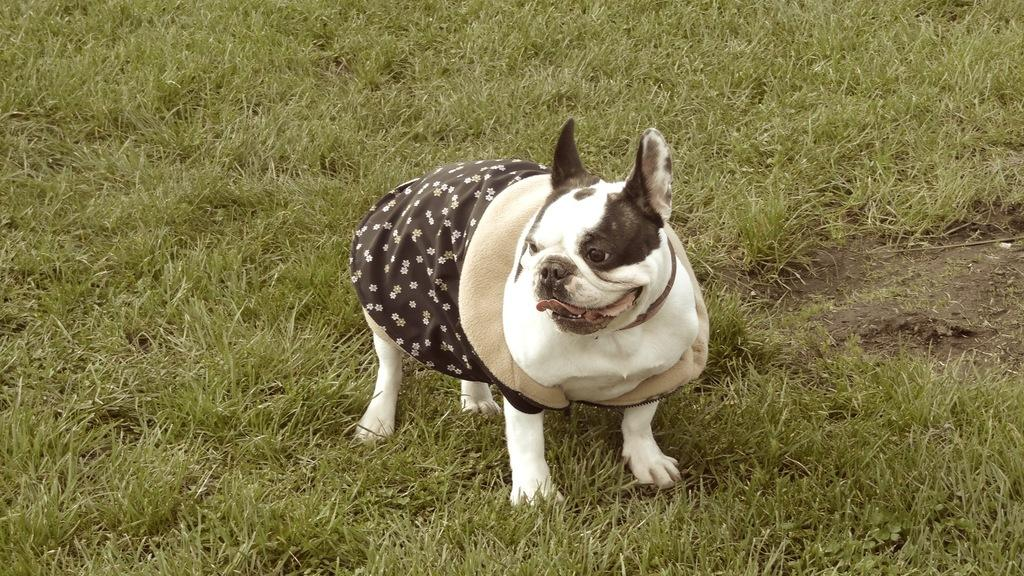What type of animal is in the image? There is a dog in the image. What is the dog standing on in the image? The dog is on green grass. How many legs does the ornament have in the image? There is no ornament present in the image, so it is not possible to determine how many legs it might have. 